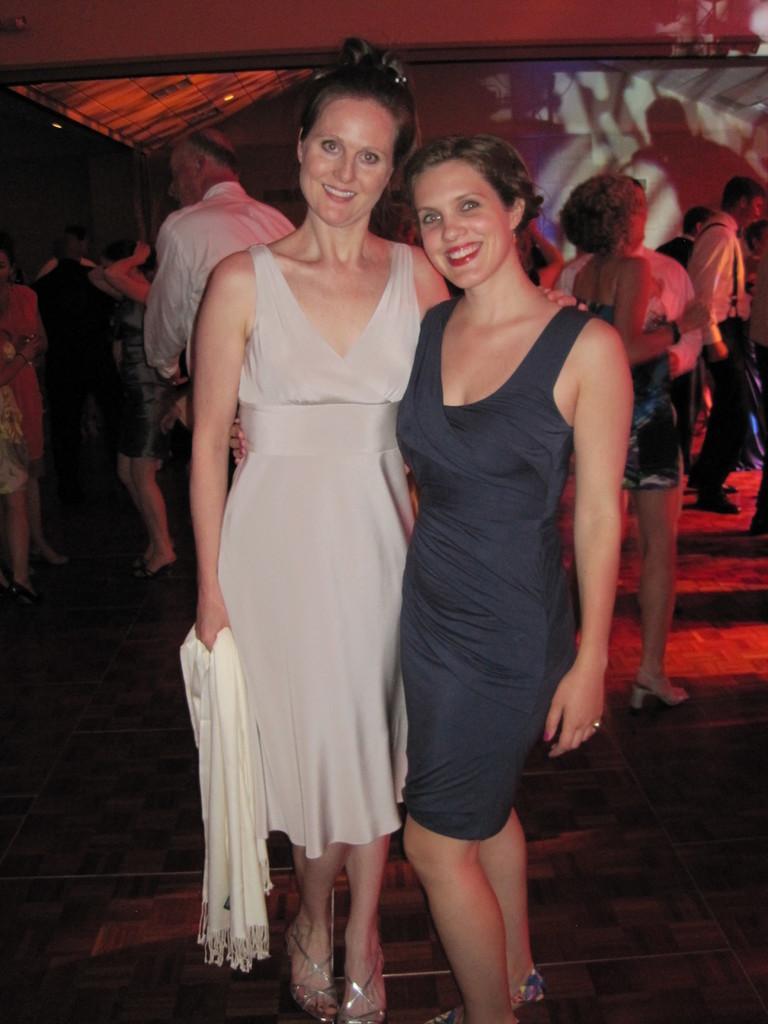In one or two sentences, can you explain what this image depicts? In this image, we can see two women are standing on the floor. They are seeing and smiling. Here a woman is holding a cloth. Background we can see a group of people. 